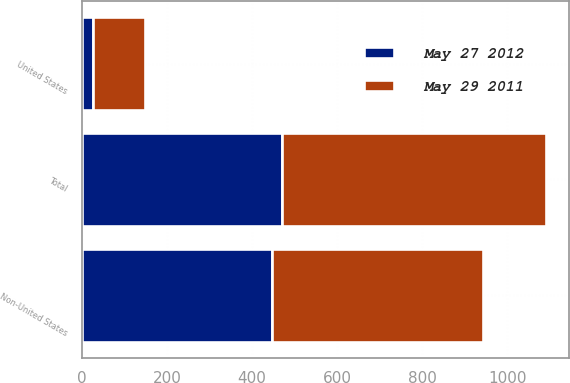Convert chart. <chart><loc_0><loc_0><loc_500><loc_500><stacked_bar_chart><ecel><fcel>United States<fcel>Non-United States<fcel>Total<nl><fcel>May 27 2012<fcel>25.7<fcel>445.5<fcel>471.2<nl><fcel>May 29 2011<fcel>123.7<fcel>495.9<fcel>619.6<nl></chart> 